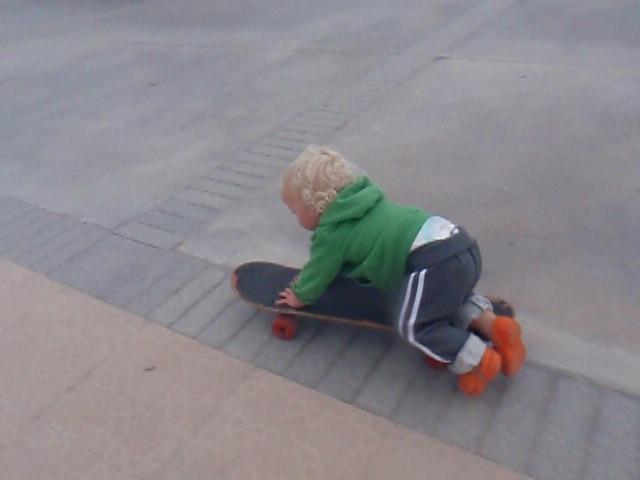How many children are sitting down?
Give a very brief answer. 0. How many people are in the photo?
Give a very brief answer. 1. How many cars are behind a pole?
Give a very brief answer. 0. 